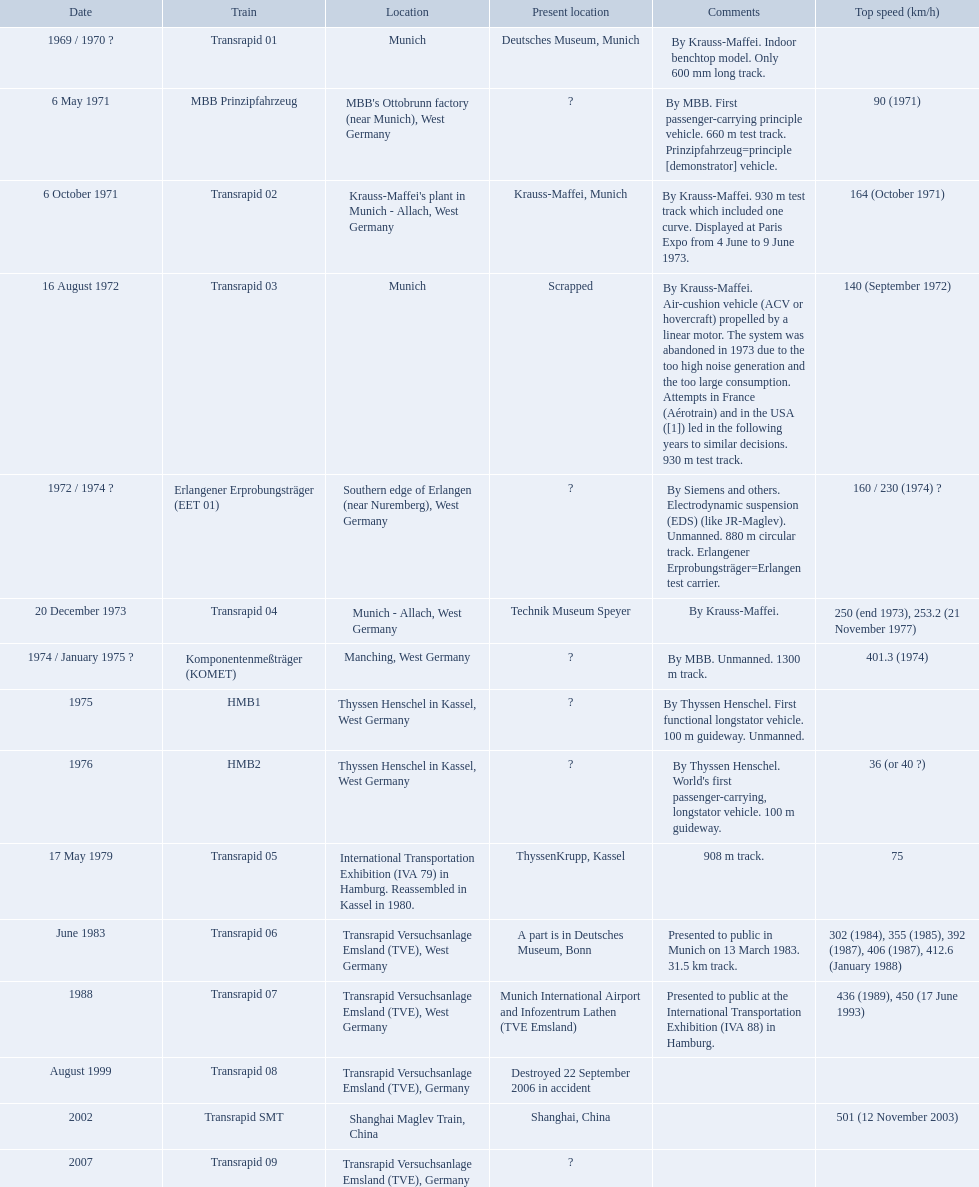What are all trains? Transrapid 01, MBB Prinzipfahrzeug, Transrapid 02, Transrapid 03, Erlangener Erprobungsträger (EET 01), Transrapid 04, Komponentenmeßträger (KOMET), HMB1, HMB2, Transrapid 05, Transrapid 06, Transrapid 07, Transrapid 08, Transrapid SMT, Transrapid 09. Which of all location of trains are known? Deutsches Museum, Munich, Krauss-Maffei, Munich, Scrapped, Technik Museum Speyer, ThyssenKrupp, Kassel, A part is in Deutsches Museum, Bonn, Munich International Airport and Infozentrum Lathen (TVE Emsland), Destroyed 22 September 2006 in accident, Shanghai, China. Which of those trains were scrapped? Transrapid 03. What are all of the transrapid trains? Transrapid 01, Transrapid 02, Transrapid 03, Transrapid 04, Transrapid 05, Transrapid 06, Transrapid 07, Transrapid 08, Transrapid SMT, Transrapid 09. Of those, which train had to be scrapped? Transrapid 03. What are all the transrapid trains? Transrapid 01, Transrapid 02, Transrapid 03, Transrapid 04, Transrapid 05, Transrapid 06, Transrapid 07, Transrapid 08, Transrapid SMT, Transrapid 09. Among them, which one had to be dismantled? Transrapid 03. Which trains had a maximum speed mentioned? MBB Prinzipfahrzeug, Transrapid 02, Transrapid 03, Erlangener Erprobungsträger (EET 01), Transrapid 04, Komponentenmeßträger (KOMET), HMB2, Transrapid 05, Transrapid 06, Transrapid 07, Transrapid SMT. Which ones indicate munich as a place? MBB Prinzipfahrzeug, Transrapid 02, Transrapid 03. Of these, which ones have a known current location? Transrapid 02, Transrapid 03. Which of those is not functional anymore? Transrapid 03. What are every train? Transrapid 01, MBB Prinzipfahrzeug, Transrapid 02, Transrapid 03, Erlangener Erprobungsträger (EET 01), Transrapid 04, Komponentenmeßträger (KOMET), HMB1, HMB2, Transrapid 05, Transrapid 06, Transrapid 07, Transrapid 08, Transrapid SMT, Transrapid 09. Which of every train location is identified? Deutsches Museum, Munich, Krauss-Maffei, Munich, Scrapped, Technik Museum Speyer, ThyssenKrupp, Kassel, A part is in Deutsches Museum, Bonn, Munich International Airport and Infozentrum Lathen (TVE Emsland), Destroyed 22 September 2006 in accident, Shanghai, China. Which of those trains were dismantled? Transrapid 03. What is the maximum speed achieved by any trains displayed here? 501 (12 November 2003). Which train has attained a top speed of 501? Transrapid SMT. What encompasses all trains? Transrapid 01, MBB Prinzipfahrzeug, Transrapid 02, Transrapid 03, Erlangener Erprobungsträger (EET 01), Transrapid 04, Komponentenmeßträger (KOMET), HMB1, HMB2, Transrapid 05, Transrapid 06, Transrapid 07, Transrapid 08, Transrapid SMT, Transrapid 09. Could you parse the entire table as a dict? {'header': ['Date', 'Train', 'Location', 'Present location', 'Comments', 'Top speed (km/h)'], 'rows': [['1969 / 1970\xa0?', 'Transrapid 01', 'Munich', 'Deutsches Museum, Munich', 'By Krauss-Maffei. Indoor benchtop model. Only 600\xa0mm long track.', ''], ['6 May 1971', 'MBB Prinzipfahrzeug', "MBB's Ottobrunn factory (near Munich), West Germany", '?', 'By MBB. First passenger-carrying principle vehicle. 660 m test track. Prinzipfahrzeug=principle [demonstrator] vehicle.', '90 (1971)'], ['6 October 1971', 'Transrapid 02', "Krauss-Maffei's plant in Munich - Allach, West Germany", 'Krauss-Maffei, Munich', 'By Krauss-Maffei. 930 m test track which included one curve. Displayed at Paris Expo from 4 June to 9 June 1973.', '164 (October 1971)'], ['16 August 1972', 'Transrapid 03', 'Munich', 'Scrapped', 'By Krauss-Maffei. Air-cushion vehicle (ACV or hovercraft) propelled by a linear motor. The system was abandoned in 1973 due to the too high noise generation and the too large consumption. Attempts in France (Aérotrain) and in the USA ([1]) led in the following years to similar decisions. 930 m test track.', '140 (September 1972)'], ['1972 / 1974\xa0?', 'Erlangener Erprobungsträger (EET 01)', 'Southern edge of Erlangen (near Nuremberg), West Germany', '?', 'By Siemens and others. Electrodynamic suspension (EDS) (like JR-Maglev). Unmanned. 880 m circular track. Erlangener Erprobungsträger=Erlangen test carrier.', '160 / 230 (1974)\xa0?'], ['20 December 1973', 'Transrapid 04', 'Munich - Allach, West Germany', 'Technik Museum Speyer', 'By Krauss-Maffei.', '250 (end 1973), 253.2 (21 November 1977)'], ['1974 / January 1975\xa0?', 'Komponentenmeßträger (KOMET)', 'Manching, West Germany', '?', 'By MBB. Unmanned. 1300 m track.', '401.3 (1974)'], ['1975', 'HMB1', 'Thyssen Henschel in Kassel, West Germany', '?', 'By Thyssen Henschel. First functional longstator vehicle. 100 m guideway. Unmanned.', ''], ['1976', 'HMB2', 'Thyssen Henschel in Kassel, West Germany', '?', "By Thyssen Henschel. World's first passenger-carrying, longstator vehicle. 100 m guideway.", '36 (or 40\xa0?)'], ['17 May 1979', 'Transrapid 05', 'International Transportation Exhibition (IVA 79) in Hamburg. Reassembled in Kassel in 1980.', 'ThyssenKrupp, Kassel', '908 m track.', '75'], ['June 1983', 'Transrapid 06', 'Transrapid Versuchsanlage Emsland (TVE), West Germany', 'A part is in Deutsches Museum, Bonn', 'Presented to public in Munich on 13 March 1983. 31.5\xa0km track.', '302 (1984), 355 (1985), 392 (1987), 406 (1987), 412.6 (January 1988)'], ['1988', 'Transrapid 07', 'Transrapid Versuchsanlage Emsland (TVE), West Germany', 'Munich International Airport and Infozentrum Lathen (TVE Emsland)', 'Presented to public at the International Transportation Exhibition (IVA 88) in Hamburg.', '436 (1989), 450 (17 June 1993)'], ['August 1999', 'Transrapid 08', 'Transrapid Versuchsanlage Emsland (TVE), Germany', 'Destroyed 22 September 2006 in accident', '', ''], ['2002', 'Transrapid SMT', 'Shanghai Maglev Train, China', 'Shanghai, China', '', '501 (12 November 2003)'], ['2007', 'Transrapid 09', 'Transrapid Versuchsanlage Emsland (TVE), Germany', '?', '', '']]} Which of all train sites are acknowledged? Deutsches Museum, Munich, Krauss-Maffei, Munich, Scrapped, Technik Museum Speyer, ThyssenKrupp, Kassel, A part is in Deutsches Museum, Bonn, Munich International Airport and Infozentrum Lathen (TVE Emsland), Destroyed 22 September 2006 in accident, Shanghai, China. Which of those trains were disassembled? Transrapid 03. What is the complete list of trains? Transrapid 01, MBB Prinzipfahrzeug, Transrapid 02, Transrapid 03, Erlangener Erprobungsträger (EET 01), Transrapid 04, Komponentenmeßträger (KOMET), HMB1, HMB2, Transrapid 05, Transrapid 06, Transrapid 07, Transrapid 08, Transrapid SMT, Transrapid 09. Which train locations are identified? Deutsches Museum, Munich, Krauss-Maffei, Munich, Scrapped, Technik Museum Speyer, ThyssenKrupp, Kassel, A part is in Deutsches Museum, Bonn, Munich International Airport and Infozentrum Lathen (TVE Emsland), Destroyed 22 September 2006 in accident, Shanghai, China. Which of these trains have been dismantled? Transrapid 03. What are the details of every train? Transrapid 01, MBB Prinzipfahrzeug, Transrapid 02, Transrapid 03, Erlangener Erprobungsträger (EET 01), Transrapid 04, Komponentenmeßträger (KOMET), HMB1, HMB2, Transrapid 05, Transrapid 06, Transrapid 07, Transrapid 08, Transrapid SMT, Transrapid 09. Are the whereabouts of all trains known? Deutsches Museum, Munich, Krauss-Maffei, Munich, Scrapped, Technik Museum Speyer, ThyssenKrupp, Kassel, A part is in Deutsches Museum, Bonn, Munich International Airport and Infozentrum Lathen (TVE Emsland), Destroyed 22 September 2006 in accident, Shanghai, China. Which ones have been decommissioned? Transrapid 03. For which trains is the maximum speed provided? MBB Prinzipfahrzeug, Transrapid 02, Transrapid 03, Erlangener Erprobungsträger (EET 01), Transrapid 04, Komponentenmeßträger (KOMET), HMB2, Transrapid 05, Transrapid 06, Transrapid 07, Transrapid SMT. Which ones indicate munich as a location? MBB Prinzipfahrzeug, Transrapid 02, Transrapid 03. Out of these, which ones have an identifiable present location? Transrapid 02, Transrapid 03. Which among those are not operational anymore? Transrapid 03. What is the highest speed attained by any of the trains displayed here? 501 (12 November 2003). Which train has achieved a top speed of 501? Transrapid SMT. What is the maximum speed that any trains shown here have reached? 501 (12 November 2003). Which train managed to reach a top speed of 501? Transrapid SMT. 